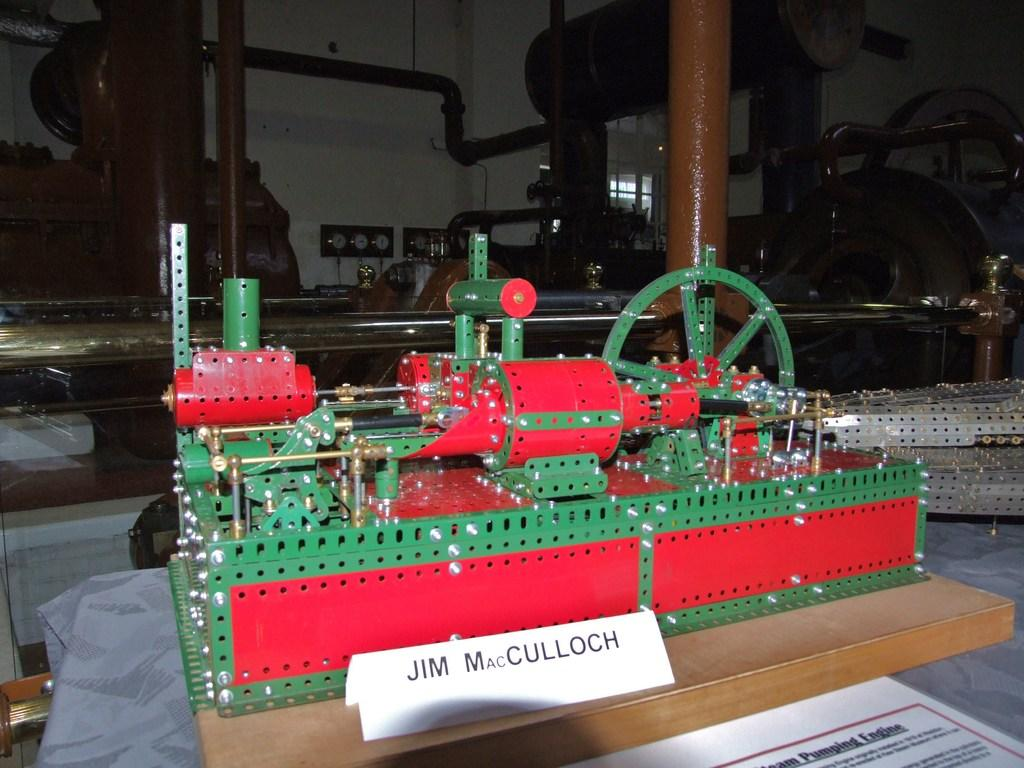What is the main object in the image? There is a machine in the image. What can be seen in the middle of the image? There are pipes in the middle of the image. What type of trousers is the machine wearing in the image? There are no trousers present in the image, as the machine is an inanimate object and does not wear clothing. 